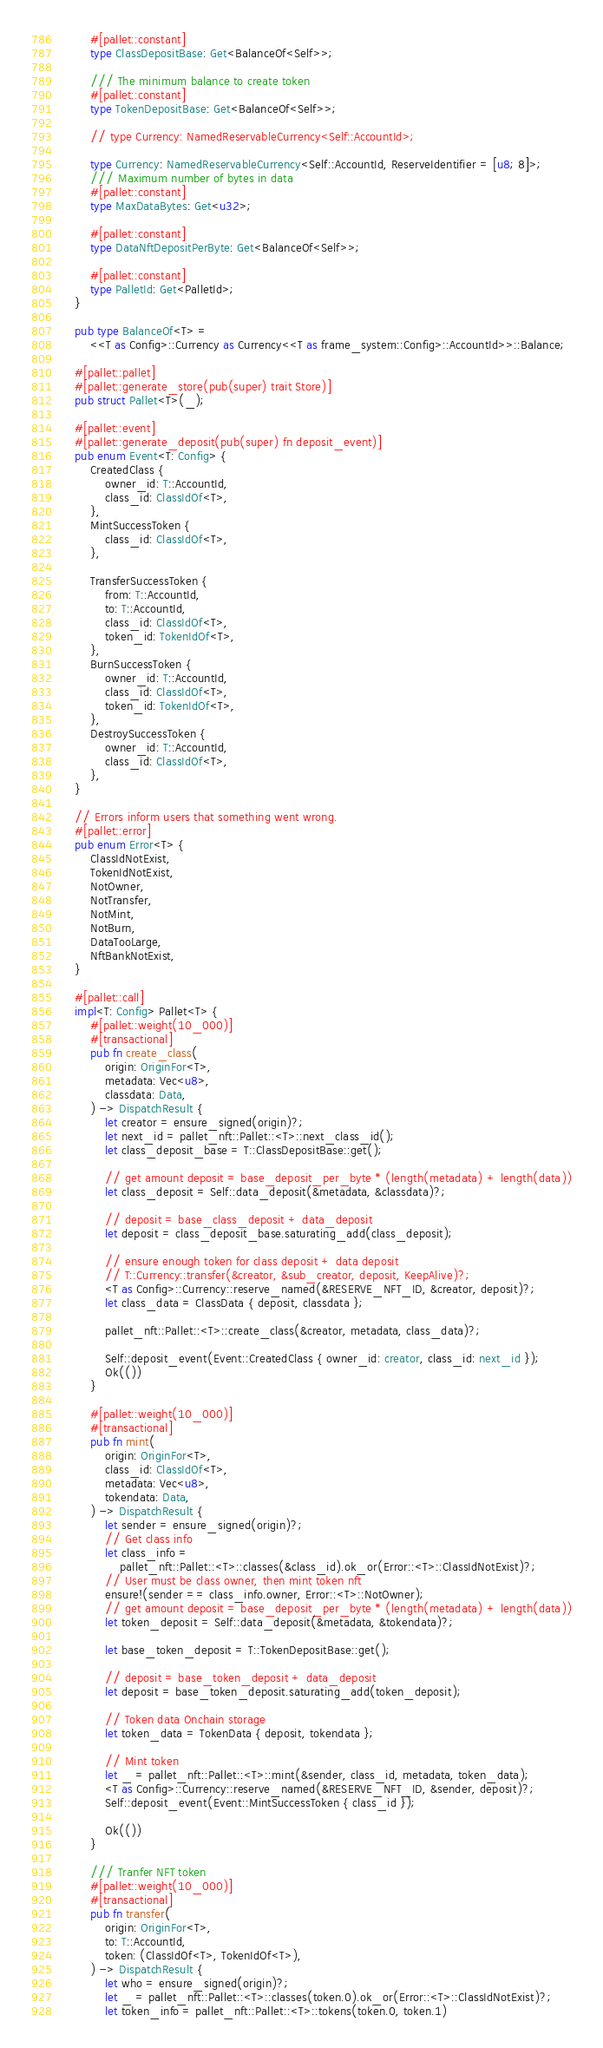<code> <loc_0><loc_0><loc_500><loc_500><_Rust_>		#[pallet::constant]
		type ClassDepositBase: Get<BalanceOf<Self>>;

		/// The minimum balance to create token
		#[pallet::constant]
		type TokenDepositBase: Get<BalanceOf<Self>>;

		// type Currency: NamedReservableCurrency<Self::AccountId>;

		type Currency: NamedReservableCurrency<Self::AccountId, ReserveIdentifier = [u8; 8]>;
		/// Maximum number of bytes in data
		#[pallet::constant]
		type MaxDataBytes: Get<u32>;

		#[pallet::constant]
		type DataNftDepositPerByte: Get<BalanceOf<Self>>;

		#[pallet::constant]
		type PalletId: Get<PalletId>;
	}

	pub type BalanceOf<T> =
		<<T as Config>::Currency as Currency<<T as frame_system::Config>::AccountId>>::Balance;

	#[pallet::pallet]
	#[pallet::generate_store(pub(super) trait Store)]
	pub struct Pallet<T>(_);

	#[pallet::event]
	#[pallet::generate_deposit(pub(super) fn deposit_event)]
	pub enum Event<T: Config> {
		CreatedClass {
			owner_id: T::AccountId,
			class_id: ClassIdOf<T>,
		},
		MintSuccessToken {
			class_id: ClassIdOf<T>,
		},

		TransferSuccessToken {
			from: T::AccountId,
			to: T::AccountId,
			class_id: ClassIdOf<T>,
			token_id: TokenIdOf<T>,
		},
		BurnSuccessToken {
			owner_id: T::AccountId,
			class_id: ClassIdOf<T>,
			token_id: TokenIdOf<T>,
		},
		DestroySuccessToken {
			owner_id: T::AccountId,
			class_id: ClassIdOf<T>,
		},
	}

	// Errors inform users that something went wrong.
	#[pallet::error]
	pub enum Error<T> {
		ClassIdNotExist,
		TokenIdNotExist,
		NotOwner,
		NotTransfer,
		NotMint,
		NotBurn,
		DataTooLarge,
		NftBankNotExist,
	}

	#[pallet::call]
	impl<T: Config> Pallet<T> {
		#[pallet::weight(10_000)]
		#[transactional]
		pub fn create_class(
			origin: OriginFor<T>,
			metadata: Vec<u8>,
			classdata: Data,
		) -> DispatchResult {
			let creator = ensure_signed(origin)?;
			let next_id = pallet_nft::Pallet::<T>::next_class_id();
			let class_deposit_base = T::ClassDepositBase::get();

			// get amount deposit = base_deposit_per_byte * (length(metadata) + length(data))
			let class_deposit = Self::data_deposit(&metadata, &classdata)?;

			// deposit = base_class_deposit + data_deposit
			let deposit = class_deposit_base.saturating_add(class_deposit);

			// ensure enough token for class deposit + data deposit
			// T::Currency::transfer(&creator, &sub_creator, deposit, KeepAlive)?;
			<T as Config>::Currency::reserve_named(&RESERVE_NFT_ID, &creator, deposit)?;
			let class_data = ClassData { deposit, classdata };

			pallet_nft::Pallet::<T>::create_class(&creator, metadata, class_data)?;

			Self::deposit_event(Event::CreatedClass { owner_id: creator, class_id: next_id });
			Ok(())
		}

		#[pallet::weight(10_000)]
		#[transactional]
		pub fn mint(
			origin: OriginFor<T>,
			class_id: ClassIdOf<T>,
			metadata: Vec<u8>,
			tokendata: Data,
		) -> DispatchResult {
			let sender = ensure_signed(origin)?;
			// Get class info
			let class_info =
				pallet_nft::Pallet::<T>::classes(&class_id).ok_or(Error::<T>::ClassIdNotExist)?;
			// User must be class owner, then mint token nft
			ensure!(sender == class_info.owner, Error::<T>::NotOwner);
			// get amount deposit = base_deposit_per_byte * (length(metadata) + length(data))
			let token_deposit = Self::data_deposit(&metadata, &tokendata)?;

			let base_token_deposit = T::TokenDepositBase::get();

			// deposit = base_token_deposit + data_deposit
			let deposit = base_token_deposit.saturating_add(token_deposit);

			// Token data Onchain storage
			let token_data = TokenData { deposit, tokendata };

			// Mint token
			let _ = pallet_nft::Pallet::<T>::mint(&sender, class_id, metadata, token_data);
			<T as Config>::Currency::reserve_named(&RESERVE_NFT_ID, &sender, deposit)?;
			Self::deposit_event(Event::MintSuccessToken { class_id });

			Ok(())
		}

		/// Tranfer NFT token
		#[pallet::weight(10_000)]
		#[transactional]
		pub fn transfer(
			origin: OriginFor<T>,
			to: T::AccountId,
			token: (ClassIdOf<T>, TokenIdOf<T>),
		) -> DispatchResult {
			let who = ensure_signed(origin)?;
			let _ = pallet_nft::Pallet::<T>::classes(token.0).ok_or(Error::<T>::ClassIdNotExist)?;
			let token_info = pallet_nft::Pallet::<T>::tokens(token.0, token.1)</code> 